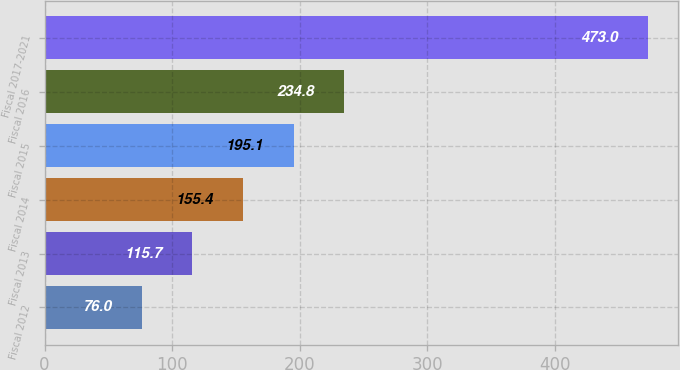Convert chart to OTSL. <chart><loc_0><loc_0><loc_500><loc_500><bar_chart><fcel>Fiscal 2012<fcel>Fiscal 2013<fcel>Fiscal 2014<fcel>Fiscal 2015<fcel>Fiscal 2016<fcel>Fiscal 2017-2021<nl><fcel>76<fcel>115.7<fcel>155.4<fcel>195.1<fcel>234.8<fcel>473<nl></chart> 